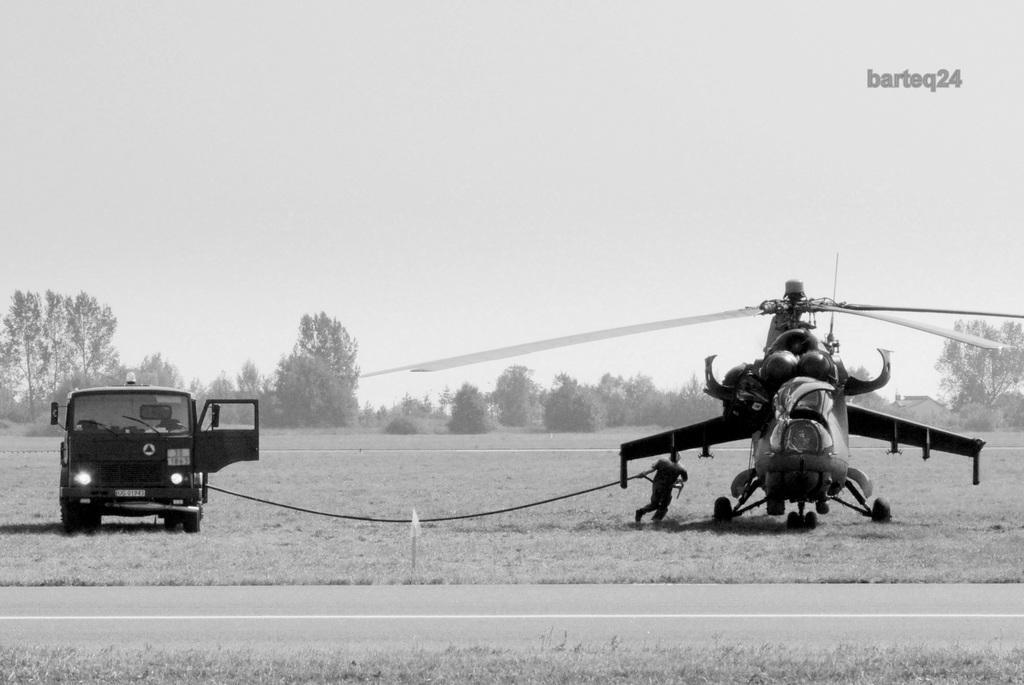How would you summarize this image in a sentence or two? It is a black and white picture. In the center of the image we can see a vehicle and a helicopter. And we can see a person is holding a rope which is attached to the vehicle. At the bottom of the image, we can see the grass and the road. In the background, we can see the sky, trees and grass. At the top right side of the image, we can see some text. 